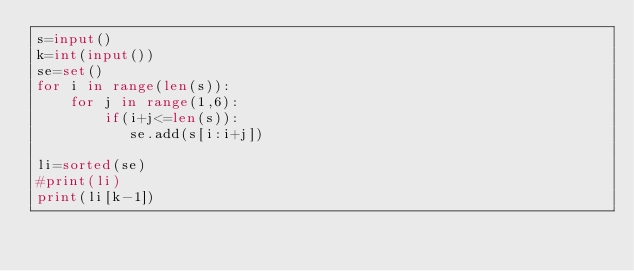Convert code to text. <code><loc_0><loc_0><loc_500><loc_500><_Python_>s=input()
k=int(input())
se=set()
for i in range(len(s)):
    for j in range(1,6):
        if(i+j<=len(s)):
           se.add(s[i:i+j])
    
li=sorted(se)
#print(li)
print(li[k-1])






</code> 